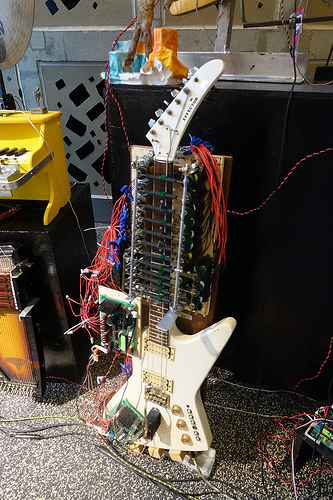<image>
Can you confirm if the guitar is on the floor? Yes. Looking at the image, I can see the guitar is positioned on top of the floor, with the floor providing support. 